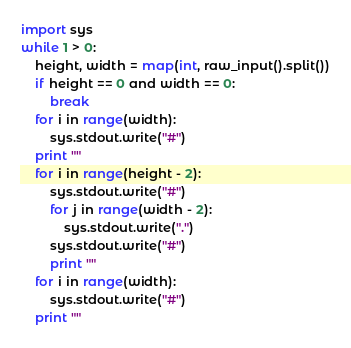<code> <loc_0><loc_0><loc_500><loc_500><_Python_>import sys
while 1 > 0:
    height, width = map(int, raw_input().split())
    if height == 0 and width == 0:
        break
    for i in range(width):
        sys.stdout.write("#")
    print ""
    for i in range(height - 2):
        sys.stdout.write("#")
        for j in range(width - 2):
            sys.stdout.write(".")
        sys.stdout.write("#")
        print ""
    for i in range(width):
        sys.stdout.write("#")
    print ""</code> 